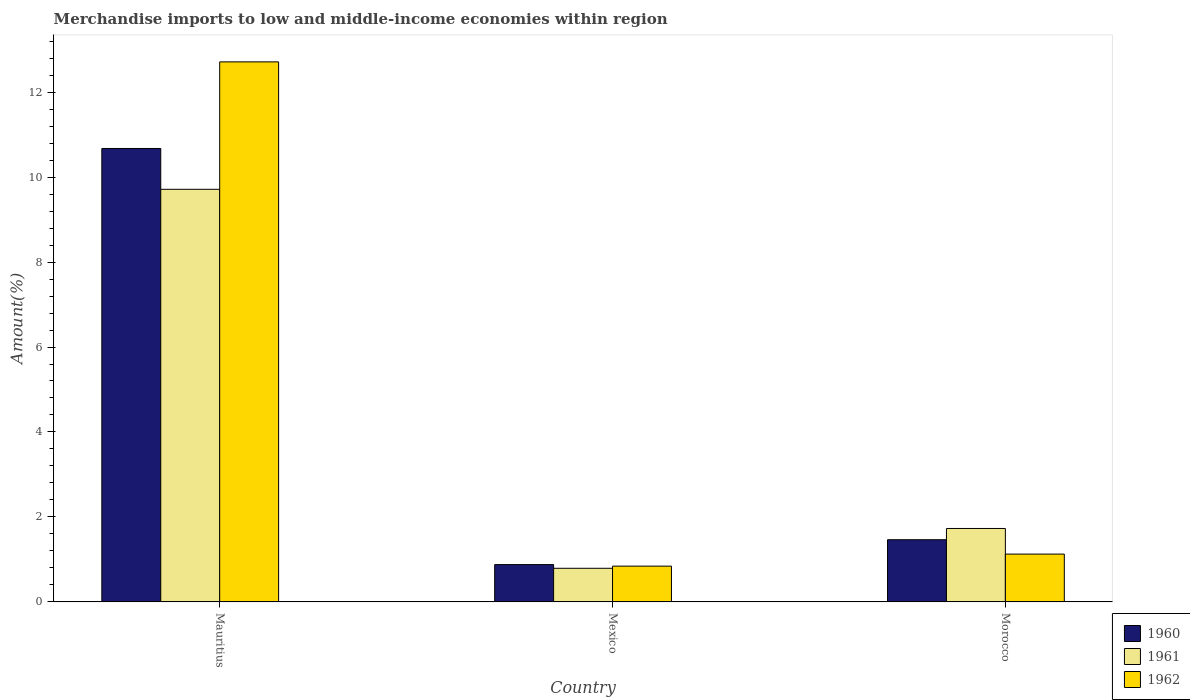How many groups of bars are there?
Keep it short and to the point. 3. Are the number of bars on each tick of the X-axis equal?
Give a very brief answer. Yes. What is the label of the 2nd group of bars from the left?
Your response must be concise. Mexico. In how many cases, is the number of bars for a given country not equal to the number of legend labels?
Provide a short and direct response. 0. What is the percentage of amount earned from merchandise imports in 1962 in Morocco?
Ensure brevity in your answer.  1.13. Across all countries, what is the maximum percentage of amount earned from merchandise imports in 1960?
Your answer should be very brief. 10.67. Across all countries, what is the minimum percentage of amount earned from merchandise imports in 1960?
Provide a short and direct response. 0.88. In which country was the percentage of amount earned from merchandise imports in 1962 maximum?
Keep it short and to the point. Mauritius. In which country was the percentage of amount earned from merchandise imports in 1960 minimum?
Provide a short and direct response. Mexico. What is the total percentage of amount earned from merchandise imports in 1961 in the graph?
Keep it short and to the point. 12.23. What is the difference between the percentage of amount earned from merchandise imports in 1962 in Mauritius and that in Mexico?
Your answer should be very brief. 11.87. What is the difference between the percentage of amount earned from merchandise imports in 1962 in Mauritius and the percentage of amount earned from merchandise imports in 1961 in Morocco?
Offer a terse response. 10.98. What is the average percentage of amount earned from merchandise imports in 1960 per country?
Your response must be concise. 4.34. What is the difference between the percentage of amount earned from merchandise imports of/in 1961 and percentage of amount earned from merchandise imports of/in 1960 in Mexico?
Your response must be concise. -0.09. In how many countries, is the percentage of amount earned from merchandise imports in 1960 greater than 1.2000000000000002 %?
Your answer should be very brief. 2. What is the ratio of the percentage of amount earned from merchandise imports in 1962 in Mauritius to that in Morocco?
Offer a terse response. 11.28. Is the percentage of amount earned from merchandise imports in 1960 in Mauritius less than that in Morocco?
Your answer should be very brief. No. What is the difference between the highest and the second highest percentage of amount earned from merchandise imports in 1961?
Provide a short and direct response. -8.92. What is the difference between the highest and the lowest percentage of amount earned from merchandise imports in 1961?
Your answer should be very brief. 8.92. Is the sum of the percentage of amount earned from merchandise imports in 1960 in Mauritius and Mexico greater than the maximum percentage of amount earned from merchandise imports in 1961 across all countries?
Keep it short and to the point. Yes. What does the 1st bar from the left in Mexico represents?
Ensure brevity in your answer.  1960. Is it the case that in every country, the sum of the percentage of amount earned from merchandise imports in 1960 and percentage of amount earned from merchandise imports in 1961 is greater than the percentage of amount earned from merchandise imports in 1962?
Keep it short and to the point. Yes. Are all the bars in the graph horizontal?
Ensure brevity in your answer.  No. How many countries are there in the graph?
Ensure brevity in your answer.  3. Does the graph contain any zero values?
Offer a terse response. No. Where does the legend appear in the graph?
Ensure brevity in your answer.  Bottom right. How many legend labels are there?
Ensure brevity in your answer.  3. How are the legend labels stacked?
Provide a succinct answer. Vertical. What is the title of the graph?
Make the answer very short. Merchandise imports to low and middle-income economies within region. What is the label or title of the X-axis?
Your response must be concise. Country. What is the label or title of the Y-axis?
Keep it short and to the point. Amount(%). What is the Amount(%) of 1960 in Mauritius?
Provide a succinct answer. 10.67. What is the Amount(%) in 1961 in Mauritius?
Your answer should be compact. 9.71. What is the Amount(%) of 1962 in Mauritius?
Offer a very short reply. 12.71. What is the Amount(%) of 1960 in Mexico?
Give a very brief answer. 0.88. What is the Amount(%) in 1961 in Mexico?
Ensure brevity in your answer.  0.79. What is the Amount(%) of 1962 in Mexico?
Offer a terse response. 0.84. What is the Amount(%) of 1960 in Morocco?
Provide a succinct answer. 1.46. What is the Amount(%) of 1961 in Morocco?
Your answer should be compact. 1.73. What is the Amount(%) in 1962 in Morocco?
Your answer should be compact. 1.13. Across all countries, what is the maximum Amount(%) of 1960?
Make the answer very short. 10.67. Across all countries, what is the maximum Amount(%) of 1961?
Your response must be concise. 9.71. Across all countries, what is the maximum Amount(%) of 1962?
Provide a succinct answer. 12.71. Across all countries, what is the minimum Amount(%) in 1960?
Provide a short and direct response. 0.88. Across all countries, what is the minimum Amount(%) of 1961?
Ensure brevity in your answer.  0.79. Across all countries, what is the minimum Amount(%) of 1962?
Provide a succinct answer. 0.84. What is the total Amount(%) in 1960 in the graph?
Ensure brevity in your answer.  13.02. What is the total Amount(%) in 1961 in the graph?
Provide a short and direct response. 12.23. What is the total Amount(%) in 1962 in the graph?
Make the answer very short. 14.68. What is the difference between the Amount(%) in 1960 in Mauritius and that in Mexico?
Your response must be concise. 9.79. What is the difference between the Amount(%) in 1961 in Mauritius and that in Mexico?
Ensure brevity in your answer.  8.92. What is the difference between the Amount(%) in 1962 in Mauritius and that in Mexico?
Make the answer very short. 11.87. What is the difference between the Amount(%) in 1960 in Mauritius and that in Morocco?
Your answer should be compact. 9.21. What is the difference between the Amount(%) in 1961 in Mauritius and that in Morocco?
Give a very brief answer. 7.98. What is the difference between the Amount(%) of 1962 in Mauritius and that in Morocco?
Your answer should be compact. 11.58. What is the difference between the Amount(%) of 1960 in Mexico and that in Morocco?
Provide a short and direct response. -0.59. What is the difference between the Amount(%) in 1961 in Mexico and that in Morocco?
Your answer should be very brief. -0.94. What is the difference between the Amount(%) of 1962 in Mexico and that in Morocco?
Offer a very short reply. -0.28. What is the difference between the Amount(%) of 1960 in Mauritius and the Amount(%) of 1961 in Mexico?
Give a very brief answer. 9.88. What is the difference between the Amount(%) of 1960 in Mauritius and the Amount(%) of 1962 in Mexico?
Give a very brief answer. 9.83. What is the difference between the Amount(%) in 1961 in Mauritius and the Amount(%) in 1962 in Mexico?
Keep it short and to the point. 8.87. What is the difference between the Amount(%) of 1960 in Mauritius and the Amount(%) of 1961 in Morocco?
Make the answer very short. 8.94. What is the difference between the Amount(%) in 1960 in Mauritius and the Amount(%) in 1962 in Morocco?
Your answer should be very brief. 9.55. What is the difference between the Amount(%) of 1961 in Mauritius and the Amount(%) of 1962 in Morocco?
Provide a succinct answer. 8.59. What is the difference between the Amount(%) of 1960 in Mexico and the Amount(%) of 1961 in Morocco?
Your response must be concise. -0.85. What is the difference between the Amount(%) of 1960 in Mexico and the Amount(%) of 1962 in Morocco?
Your response must be concise. -0.25. What is the difference between the Amount(%) of 1961 in Mexico and the Amount(%) of 1962 in Morocco?
Provide a succinct answer. -0.33. What is the average Amount(%) of 1960 per country?
Keep it short and to the point. 4.34. What is the average Amount(%) in 1961 per country?
Give a very brief answer. 4.08. What is the average Amount(%) in 1962 per country?
Your answer should be compact. 4.89. What is the difference between the Amount(%) of 1960 and Amount(%) of 1961 in Mauritius?
Give a very brief answer. 0.96. What is the difference between the Amount(%) in 1960 and Amount(%) in 1962 in Mauritius?
Your answer should be very brief. -2.04. What is the difference between the Amount(%) in 1961 and Amount(%) in 1962 in Mauritius?
Ensure brevity in your answer.  -3. What is the difference between the Amount(%) of 1960 and Amount(%) of 1961 in Mexico?
Offer a very short reply. 0.09. What is the difference between the Amount(%) of 1960 and Amount(%) of 1962 in Mexico?
Your response must be concise. 0.04. What is the difference between the Amount(%) in 1961 and Amount(%) in 1962 in Mexico?
Your answer should be compact. -0.05. What is the difference between the Amount(%) of 1960 and Amount(%) of 1961 in Morocco?
Your answer should be compact. -0.27. What is the difference between the Amount(%) in 1960 and Amount(%) in 1962 in Morocco?
Make the answer very short. 0.34. What is the difference between the Amount(%) of 1961 and Amount(%) of 1962 in Morocco?
Your response must be concise. 0.6. What is the ratio of the Amount(%) in 1960 in Mauritius to that in Mexico?
Your response must be concise. 12.14. What is the ratio of the Amount(%) in 1961 in Mauritius to that in Mexico?
Make the answer very short. 12.26. What is the ratio of the Amount(%) of 1962 in Mauritius to that in Mexico?
Keep it short and to the point. 15.08. What is the ratio of the Amount(%) in 1960 in Mauritius to that in Morocco?
Give a very brief answer. 7.29. What is the ratio of the Amount(%) in 1961 in Mauritius to that in Morocco?
Ensure brevity in your answer.  5.62. What is the ratio of the Amount(%) of 1962 in Mauritius to that in Morocco?
Offer a very short reply. 11.28. What is the ratio of the Amount(%) in 1960 in Mexico to that in Morocco?
Offer a very short reply. 0.6. What is the ratio of the Amount(%) in 1961 in Mexico to that in Morocco?
Your response must be concise. 0.46. What is the ratio of the Amount(%) in 1962 in Mexico to that in Morocco?
Give a very brief answer. 0.75. What is the difference between the highest and the second highest Amount(%) in 1960?
Your answer should be very brief. 9.21. What is the difference between the highest and the second highest Amount(%) of 1961?
Make the answer very short. 7.98. What is the difference between the highest and the second highest Amount(%) of 1962?
Offer a terse response. 11.58. What is the difference between the highest and the lowest Amount(%) in 1960?
Offer a terse response. 9.79. What is the difference between the highest and the lowest Amount(%) of 1961?
Offer a very short reply. 8.92. What is the difference between the highest and the lowest Amount(%) of 1962?
Provide a short and direct response. 11.87. 